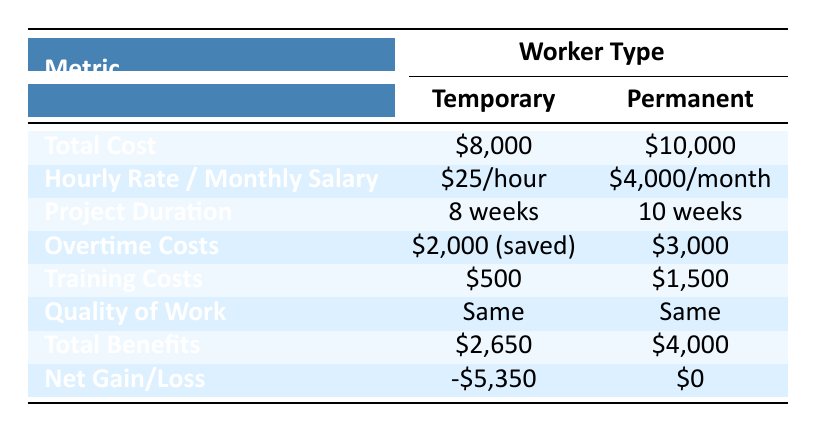What is the total cost of using temporary workers for the project? The total cost for temporary workers is listed in the table as $8,000.
Answer: $8,000 What is the difference in training costs between temporary and permanent workers? The training cost for temporary workers is $500, while for permanent workers it is $1,500. The difference is calculated as $1,500 - $500 = $1,000.
Answer: $1,000 Did using temporary workers result in any overtime costs? The overtime costs saved when using temporary workers is listed as $2,000, indicating that there are no additional overtime costs incurred.
Answer: Yes What are the total benefits of using permanent workers? The total benefits for permanent workers is given in the table as $4,000.
Answer: $4,000 Which option results in a larger net gain or smaller loss? The net gain/loss for temporary workers is -$5,350 while for permanent workers it is $0. The higher value (less negative) indicates that permanent workers result in a better financial outcome.
Answer: Permanent workers What is the total cost difference between using temporary and permanent workers? The table shows that the total cost for temporary workers is $8,000 and for permanent workers it is $10,000. The difference is calculated as $10,000 - $8,000 = $2,000.
Answer: $2,000 Is the quality of work distinct between temporary and permanent workers? The table indicates that the quality of work for both temporary and permanent workers is the same, as stated explicitly.
Answer: No What is the total duration difference for completing the project using temporary workers versus permanent workers? The project duration for temporary workers is 8 weeks and for permanent workers it is 10 weeks. The duration difference is 10 weeks - 8 weeks = 2 weeks shorter for temporary workers.
Answer: 2 weeks 